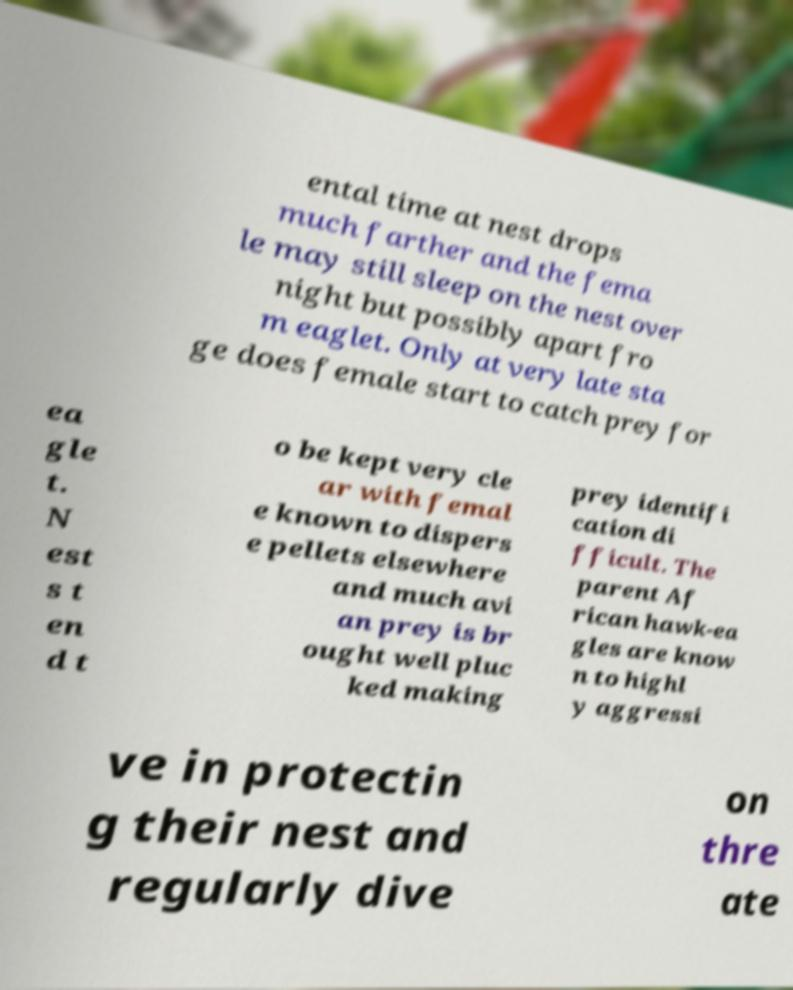Please identify and transcribe the text found in this image. ental time at nest drops much farther and the fema le may still sleep on the nest over night but possibly apart fro m eaglet. Only at very late sta ge does female start to catch prey for ea gle t. N est s t en d t o be kept very cle ar with femal e known to dispers e pellets elsewhere and much avi an prey is br ought well pluc ked making prey identifi cation di fficult. The parent Af rican hawk-ea gles are know n to highl y aggressi ve in protectin g their nest and regularly dive on thre ate 